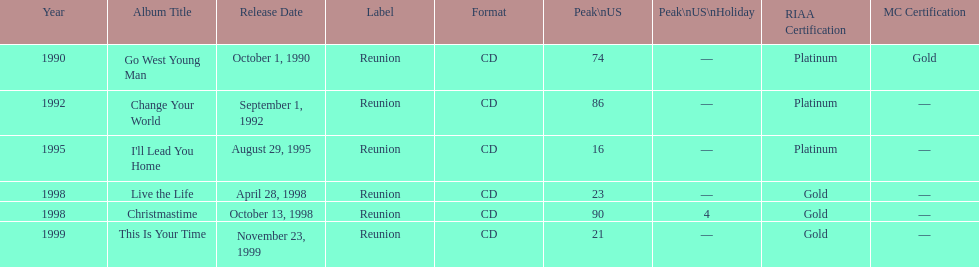What is the number of michael w smith albums that made it to the top 25 of the charts? 3. Could you parse the entire table as a dict? {'header': ['Year', 'Album Title', 'Release Date', 'Label', 'Format', 'Peak\\nUS', 'Peak\\nUS\\nHoliday', 'RIAA Certification', 'MC Certification'], 'rows': [['1990', 'Go West Young Man', 'October 1, 1990', 'Reunion', 'CD', '74', '—', 'Platinum', 'Gold'], ['1992', 'Change Your World', 'September 1, 1992', 'Reunion', 'CD', '86', '—', 'Platinum', '—'], ['1995', "I'll Lead You Home", 'August 29, 1995', 'Reunion', 'CD', '16', '—', 'Platinum', '—'], ['1998', 'Live the Life', 'April 28, 1998', 'Reunion', 'CD', '23', '—', 'Gold', '—'], ['1998', 'Christmastime', 'October 13, 1998', 'Reunion', 'CD', '90', '4', 'Gold', '—'], ['1999', 'This Is Your Time', 'November 23, 1999', 'Reunion', 'CD', '21', '—', 'Gold', '—']]} 